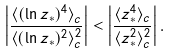<formula> <loc_0><loc_0><loc_500><loc_500>\left | \frac { \langle ( \ln z _ { \ast } ) ^ { 4 } \rangle _ { c } } { \langle ( \ln z _ { \ast } ) ^ { 2 } \rangle _ { c } ^ { 2 } } \right | < \left | \frac { \langle z _ { \ast } ^ { 4 } \rangle _ { c } } { \langle z _ { \ast } ^ { 2 } \rangle _ { c } ^ { 2 } } \right | .</formula> 